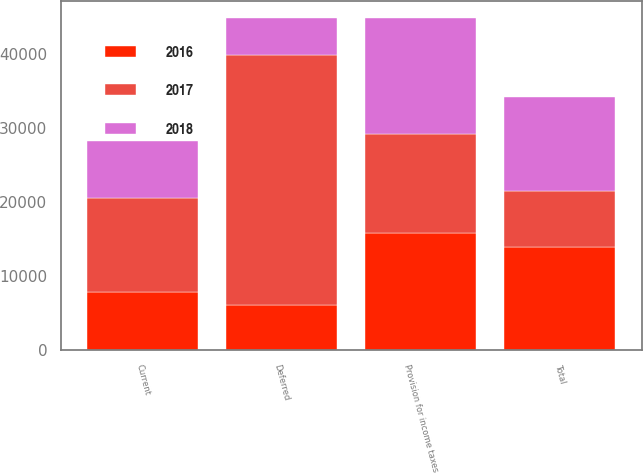<chart> <loc_0><loc_0><loc_500><loc_500><stacked_bar_chart><ecel><fcel>Current<fcel>Deferred<fcel>Total<fcel>Provision for income taxes<nl><fcel>2017<fcel>12695<fcel>33819<fcel>7606<fcel>13372<nl><fcel>2016<fcel>7842<fcel>5980<fcel>13822<fcel>15738<nl><fcel>2018<fcel>7652<fcel>5043<fcel>12695<fcel>15685<nl></chart> 